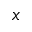<formula> <loc_0><loc_0><loc_500><loc_500>x</formula> 